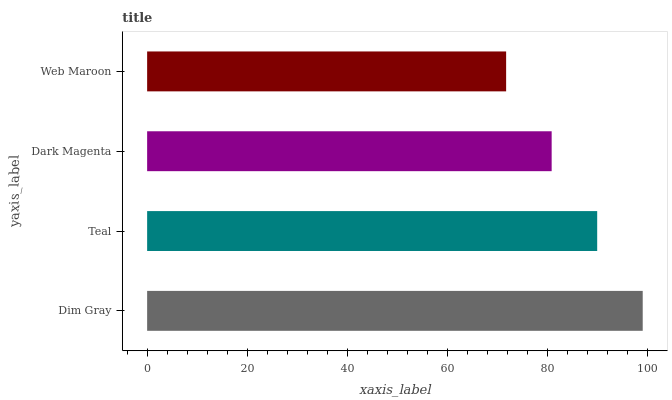Is Web Maroon the minimum?
Answer yes or no. Yes. Is Dim Gray the maximum?
Answer yes or no. Yes. Is Teal the minimum?
Answer yes or no. No. Is Teal the maximum?
Answer yes or no. No. Is Dim Gray greater than Teal?
Answer yes or no. Yes. Is Teal less than Dim Gray?
Answer yes or no. Yes. Is Teal greater than Dim Gray?
Answer yes or no. No. Is Dim Gray less than Teal?
Answer yes or no. No. Is Teal the high median?
Answer yes or no. Yes. Is Dark Magenta the low median?
Answer yes or no. Yes. Is Dark Magenta the high median?
Answer yes or no. No. Is Teal the low median?
Answer yes or no. No. 